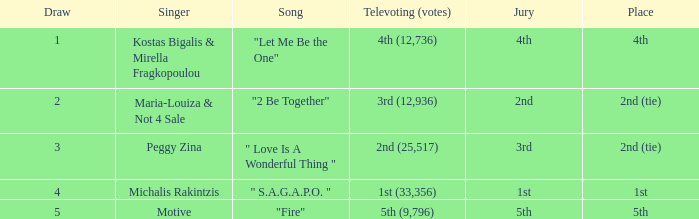What is the greatest draw that has 4th for place? 1.0. 